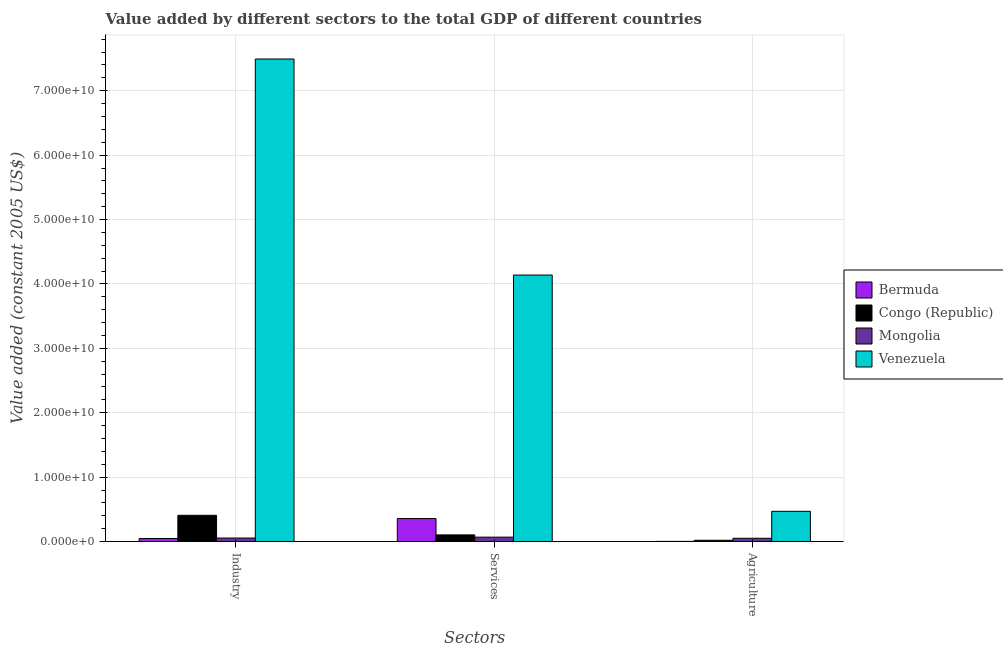How many bars are there on the 2nd tick from the left?
Ensure brevity in your answer.  4. What is the label of the 3rd group of bars from the left?
Your answer should be compact. Agriculture. What is the value added by services in Venezuela?
Ensure brevity in your answer.  4.14e+1. Across all countries, what is the maximum value added by industrial sector?
Ensure brevity in your answer.  7.49e+1. Across all countries, what is the minimum value added by services?
Your response must be concise. 6.86e+08. In which country was the value added by services maximum?
Provide a succinct answer. Venezuela. In which country was the value added by agricultural sector minimum?
Offer a very short reply. Bermuda. What is the total value added by agricultural sector in the graph?
Keep it short and to the point. 5.44e+09. What is the difference between the value added by industrial sector in Congo (Republic) and that in Venezuela?
Your answer should be very brief. -7.08e+1. What is the difference between the value added by agricultural sector in Mongolia and the value added by industrial sector in Congo (Republic)?
Give a very brief answer. -3.56e+09. What is the average value added by services per country?
Keep it short and to the point. 1.17e+1. What is the difference between the value added by agricultural sector and value added by industrial sector in Bermuda?
Your answer should be very brief. -4.44e+08. In how many countries, is the value added by agricultural sector greater than 56000000000 US$?
Offer a terse response. 0. What is the ratio of the value added by agricultural sector in Bermuda to that in Venezuela?
Offer a very short reply. 0.01. What is the difference between the highest and the second highest value added by agricultural sector?
Your response must be concise. 4.18e+09. What is the difference between the highest and the lowest value added by services?
Your response must be concise. 4.07e+1. Is the sum of the value added by industrial sector in Congo (Republic) and Mongolia greater than the maximum value added by services across all countries?
Ensure brevity in your answer.  No. What does the 4th bar from the left in Services represents?
Ensure brevity in your answer.  Venezuela. What does the 1st bar from the right in Agriculture represents?
Offer a terse response. Venezuela. Is it the case that in every country, the sum of the value added by industrial sector and value added by services is greater than the value added by agricultural sector?
Offer a terse response. Yes. How many bars are there?
Keep it short and to the point. 12. How many countries are there in the graph?
Keep it short and to the point. 4. What is the difference between two consecutive major ticks on the Y-axis?
Your answer should be very brief. 1.00e+1. Does the graph contain any zero values?
Offer a terse response. No. Does the graph contain grids?
Your answer should be compact. Yes. How are the legend labels stacked?
Your answer should be very brief. Vertical. What is the title of the graph?
Ensure brevity in your answer.  Value added by different sectors to the total GDP of different countries. Does "Canada" appear as one of the legend labels in the graph?
Your answer should be very brief. No. What is the label or title of the X-axis?
Offer a very short reply. Sectors. What is the label or title of the Y-axis?
Your response must be concise. Value added (constant 2005 US$). What is the Value added (constant 2005 US$) in Bermuda in Industry?
Give a very brief answer. 4.76e+08. What is the Value added (constant 2005 US$) of Congo (Republic) in Industry?
Ensure brevity in your answer.  4.08e+09. What is the Value added (constant 2005 US$) of Mongolia in Industry?
Give a very brief answer. 5.49e+08. What is the Value added (constant 2005 US$) of Venezuela in Industry?
Your answer should be very brief. 7.49e+1. What is the Value added (constant 2005 US$) in Bermuda in Services?
Keep it short and to the point. 3.57e+09. What is the Value added (constant 2005 US$) of Congo (Republic) in Services?
Provide a short and direct response. 1.04e+09. What is the Value added (constant 2005 US$) in Mongolia in Services?
Your answer should be compact. 6.86e+08. What is the Value added (constant 2005 US$) of Venezuela in Services?
Offer a very short reply. 4.14e+1. What is the Value added (constant 2005 US$) in Bermuda in Agriculture?
Give a very brief answer. 3.15e+07. What is the Value added (constant 2005 US$) of Congo (Republic) in Agriculture?
Your answer should be very brief. 2.03e+08. What is the Value added (constant 2005 US$) of Mongolia in Agriculture?
Provide a succinct answer. 5.12e+08. What is the Value added (constant 2005 US$) of Venezuela in Agriculture?
Keep it short and to the point. 4.70e+09. Across all Sectors, what is the maximum Value added (constant 2005 US$) of Bermuda?
Your response must be concise. 3.57e+09. Across all Sectors, what is the maximum Value added (constant 2005 US$) of Congo (Republic)?
Ensure brevity in your answer.  4.08e+09. Across all Sectors, what is the maximum Value added (constant 2005 US$) of Mongolia?
Provide a succinct answer. 6.86e+08. Across all Sectors, what is the maximum Value added (constant 2005 US$) in Venezuela?
Your answer should be very brief. 7.49e+1. Across all Sectors, what is the minimum Value added (constant 2005 US$) of Bermuda?
Ensure brevity in your answer.  3.15e+07. Across all Sectors, what is the minimum Value added (constant 2005 US$) of Congo (Republic)?
Your answer should be very brief. 2.03e+08. Across all Sectors, what is the minimum Value added (constant 2005 US$) in Mongolia?
Your answer should be very brief. 5.12e+08. Across all Sectors, what is the minimum Value added (constant 2005 US$) in Venezuela?
Your response must be concise. 4.70e+09. What is the total Value added (constant 2005 US$) in Bermuda in the graph?
Your response must be concise. 4.08e+09. What is the total Value added (constant 2005 US$) of Congo (Republic) in the graph?
Provide a short and direct response. 5.31e+09. What is the total Value added (constant 2005 US$) of Mongolia in the graph?
Your response must be concise. 1.75e+09. What is the total Value added (constant 2005 US$) in Venezuela in the graph?
Make the answer very short. 1.21e+11. What is the difference between the Value added (constant 2005 US$) in Bermuda in Industry and that in Services?
Keep it short and to the point. -3.10e+09. What is the difference between the Value added (constant 2005 US$) of Congo (Republic) in Industry and that in Services?
Your answer should be compact. 3.04e+09. What is the difference between the Value added (constant 2005 US$) of Mongolia in Industry and that in Services?
Provide a short and direct response. -1.37e+08. What is the difference between the Value added (constant 2005 US$) in Venezuela in Industry and that in Services?
Provide a succinct answer. 3.35e+1. What is the difference between the Value added (constant 2005 US$) in Bermuda in Industry and that in Agriculture?
Provide a succinct answer. 4.44e+08. What is the difference between the Value added (constant 2005 US$) in Congo (Republic) in Industry and that in Agriculture?
Keep it short and to the point. 3.87e+09. What is the difference between the Value added (constant 2005 US$) of Mongolia in Industry and that in Agriculture?
Ensure brevity in your answer.  3.64e+07. What is the difference between the Value added (constant 2005 US$) in Venezuela in Industry and that in Agriculture?
Your response must be concise. 7.02e+1. What is the difference between the Value added (constant 2005 US$) of Bermuda in Services and that in Agriculture?
Make the answer very short. 3.54e+09. What is the difference between the Value added (constant 2005 US$) in Congo (Republic) in Services and that in Agriculture?
Ensure brevity in your answer.  8.32e+08. What is the difference between the Value added (constant 2005 US$) in Mongolia in Services and that in Agriculture?
Your answer should be very brief. 1.73e+08. What is the difference between the Value added (constant 2005 US$) of Venezuela in Services and that in Agriculture?
Your answer should be very brief. 3.67e+1. What is the difference between the Value added (constant 2005 US$) of Bermuda in Industry and the Value added (constant 2005 US$) of Congo (Republic) in Services?
Offer a terse response. -5.59e+08. What is the difference between the Value added (constant 2005 US$) of Bermuda in Industry and the Value added (constant 2005 US$) of Mongolia in Services?
Ensure brevity in your answer.  -2.10e+08. What is the difference between the Value added (constant 2005 US$) in Bermuda in Industry and the Value added (constant 2005 US$) in Venezuela in Services?
Provide a succinct answer. -4.09e+1. What is the difference between the Value added (constant 2005 US$) of Congo (Republic) in Industry and the Value added (constant 2005 US$) of Mongolia in Services?
Your answer should be compact. 3.39e+09. What is the difference between the Value added (constant 2005 US$) in Congo (Republic) in Industry and the Value added (constant 2005 US$) in Venezuela in Services?
Ensure brevity in your answer.  -3.73e+1. What is the difference between the Value added (constant 2005 US$) of Mongolia in Industry and the Value added (constant 2005 US$) of Venezuela in Services?
Your response must be concise. -4.08e+1. What is the difference between the Value added (constant 2005 US$) of Bermuda in Industry and the Value added (constant 2005 US$) of Congo (Republic) in Agriculture?
Provide a succinct answer. 2.73e+08. What is the difference between the Value added (constant 2005 US$) in Bermuda in Industry and the Value added (constant 2005 US$) in Mongolia in Agriculture?
Keep it short and to the point. -3.64e+07. What is the difference between the Value added (constant 2005 US$) of Bermuda in Industry and the Value added (constant 2005 US$) of Venezuela in Agriculture?
Offer a very short reply. -4.22e+09. What is the difference between the Value added (constant 2005 US$) of Congo (Republic) in Industry and the Value added (constant 2005 US$) of Mongolia in Agriculture?
Provide a succinct answer. 3.56e+09. What is the difference between the Value added (constant 2005 US$) in Congo (Republic) in Industry and the Value added (constant 2005 US$) in Venezuela in Agriculture?
Make the answer very short. -6.18e+08. What is the difference between the Value added (constant 2005 US$) of Mongolia in Industry and the Value added (constant 2005 US$) of Venezuela in Agriculture?
Provide a succinct answer. -4.15e+09. What is the difference between the Value added (constant 2005 US$) in Bermuda in Services and the Value added (constant 2005 US$) in Congo (Republic) in Agriculture?
Provide a succinct answer. 3.37e+09. What is the difference between the Value added (constant 2005 US$) in Bermuda in Services and the Value added (constant 2005 US$) in Mongolia in Agriculture?
Make the answer very short. 3.06e+09. What is the difference between the Value added (constant 2005 US$) of Bermuda in Services and the Value added (constant 2005 US$) of Venezuela in Agriculture?
Offer a terse response. -1.12e+09. What is the difference between the Value added (constant 2005 US$) in Congo (Republic) in Services and the Value added (constant 2005 US$) in Mongolia in Agriculture?
Your answer should be very brief. 5.23e+08. What is the difference between the Value added (constant 2005 US$) of Congo (Republic) in Services and the Value added (constant 2005 US$) of Venezuela in Agriculture?
Ensure brevity in your answer.  -3.66e+09. What is the difference between the Value added (constant 2005 US$) of Mongolia in Services and the Value added (constant 2005 US$) of Venezuela in Agriculture?
Your answer should be compact. -4.01e+09. What is the average Value added (constant 2005 US$) in Bermuda per Sectors?
Your response must be concise. 1.36e+09. What is the average Value added (constant 2005 US$) in Congo (Republic) per Sectors?
Provide a short and direct response. 1.77e+09. What is the average Value added (constant 2005 US$) of Mongolia per Sectors?
Your response must be concise. 5.82e+08. What is the average Value added (constant 2005 US$) of Venezuela per Sectors?
Your answer should be very brief. 4.03e+1. What is the difference between the Value added (constant 2005 US$) of Bermuda and Value added (constant 2005 US$) of Congo (Republic) in Industry?
Ensure brevity in your answer.  -3.60e+09. What is the difference between the Value added (constant 2005 US$) of Bermuda and Value added (constant 2005 US$) of Mongolia in Industry?
Make the answer very short. -7.28e+07. What is the difference between the Value added (constant 2005 US$) of Bermuda and Value added (constant 2005 US$) of Venezuela in Industry?
Ensure brevity in your answer.  -7.44e+1. What is the difference between the Value added (constant 2005 US$) in Congo (Republic) and Value added (constant 2005 US$) in Mongolia in Industry?
Provide a succinct answer. 3.53e+09. What is the difference between the Value added (constant 2005 US$) of Congo (Republic) and Value added (constant 2005 US$) of Venezuela in Industry?
Your answer should be very brief. -7.08e+1. What is the difference between the Value added (constant 2005 US$) in Mongolia and Value added (constant 2005 US$) in Venezuela in Industry?
Offer a very short reply. -7.44e+1. What is the difference between the Value added (constant 2005 US$) of Bermuda and Value added (constant 2005 US$) of Congo (Republic) in Services?
Your answer should be compact. 2.54e+09. What is the difference between the Value added (constant 2005 US$) in Bermuda and Value added (constant 2005 US$) in Mongolia in Services?
Provide a short and direct response. 2.89e+09. What is the difference between the Value added (constant 2005 US$) in Bermuda and Value added (constant 2005 US$) in Venezuela in Services?
Give a very brief answer. -3.78e+1. What is the difference between the Value added (constant 2005 US$) of Congo (Republic) and Value added (constant 2005 US$) of Mongolia in Services?
Your answer should be compact. 3.50e+08. What is the difference between the Value added (constant 2005 US$) in Congo (Republic) and Value added (constant 2005 US$) in Venezuela in Services?
Keep it short and to the point. -4.03e+1. What is the difference between the Value added (constant 2005 US$) of Mongolia and Value added (constant 2005 US$) of Venezuela in Services?
Ensure brevity in your answer.  -4.07e+1. What is the difference between the Value added (constant 2005 US$) in Bermuda and Value added (constant 2005 US$) in Congo (Republic) in Agriculture?
Provide a succinct answer. -1.71e+08. What is the difference between the Value added (constant 2005 US$) in Bermuda and Value added (constant 2005 US$) in Mongolia in Agriculture?
Offer a very short reply. -4.81e+08. What is the difference between the Value added (constant 2005 US$) of Bermuda and Value added (constant 2005 US$) of Venezuela in Agriculture?
Keep it short and to the point. -4.66e+09. What is the difference between the Value added (constant 2005 US$) in Congo (Republic) and Value added (constant 2005 US$) in Mongolia in Agriculture?
Offer a terse response. -3.09e+08. What is the difference between the Value added (constant 2005 US$) in Congo (Republic) and Value added (constant 2005 US$) in Venezuela in Agriculture?
Offer a terse response. -4.49e+09. What is the difference between the Value added (constant 2005 US$) of Mongolia and Value added (constant 2005 US$) of Venezuela in Agriculture?
Provide a short and direct response. -4.18e+09. What is the ratio of the Value added (constant 2005 US$) of Bermuda in Industry to that in Services?
Offer a very short reply. 0.13. What is the ratio of the Value added (constant 2005 US$) in Congo (Republic) in Industry to that in Services?
Offer a terse response. 3.94. What is the ratio of the Value added (constant 2005 US$) of Mongolia in Industry to that in Services?
Give a very brief answer. 0.8. What is the ratio of the Value added (constant 2005 US$) in Venezuela in Industry to that in Services?
Your answer should be very brief. 1.81. What is the ratio of the Value added (constant 2005 US$) in Bermuda in Industry to that in Agriculture?
Offer a terse response. 15.09. What is the ratio of the Value added (constant 2005 US$) in Congo (Republic) in Industry to that in Agriculture?
Provide a short and direct response. 20.1. What is the ratio of the Value added (constant 2005 US$) in Mongolia in Industry to that in Agriculture?
Your response must be concise. 1.07. What is the ratio of the Value added (constant 2005 US$) in Venezuela in Industry to that in Agriculture?
Offer a terse response. 15.96. What is the ratio of the Value added (constant 2005 US$) of Bermuda in Services to that in Agriculture?
Provide a succinct answer. 113.32. What is the ratio of the Value added (constant 2005 US$) of Congo (Republic) in Services to that in Agriculture?
Your answer should be compact. 5.1. What is the ratio of the Value added (constant 2005 US$) of Mongolia in Services to that in Agriculture?
Your response must be concise. 1.34. What is the ratio of the Value added (constant 2005 US$) in Venezuela in Services to that in Agriculture?
Ensure brevity in your answer.  8.81. What is the difference between the highest and the second highest Value added (constant 2005 US$) in Bermuda?
Make the answer very short. 3.10e+09. What is the difference between the highest and the second highest Value added (constant 2005 US$) of Congo (Republic)?
Your response must be concise. 3.04e+09. What is the difference between the highest and the second highest Value added (constant 2005 US$) in Mongolia?
Your answer should be compact. 1.37e+08. What is the difference between the highest and the second highest Value added (constant 2005 US$) of Venezuela?
Ensure brevity in your answer.  3.35e+1. What is the difference between the highest and the lowest Value added (constant 2005 US$) in Bermuda?
Ensure brevity in your answer.  3.54e+09. What is the difference between the highest and the lowest Value added (constant 2005 US$) in Congo (Republic)?
Offer a terse response. 3.87e+09. What is the difference between the highest and the lowest Value added (constant 2005 US$) in Mongolia?
Give a very brief answer. 1.73e+08. What is the difference between the highest and the lowest Value added (constant 2005 US$) in Venezuela?
Your answer should be compact. 7.02e+1. 